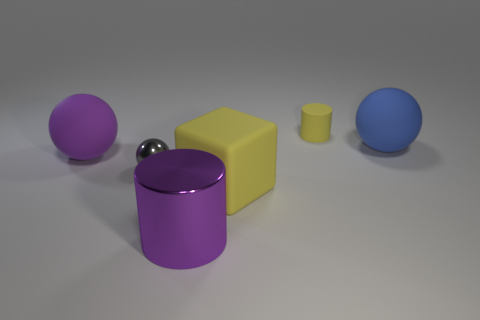Is there anything else that is the same shape as the large yellow rubber object?
Provide a short and direct response. No. What number of tiny yellow matte cylinders are on the left side of the sphere right of the yellow matte block?
Make the answer very short. 1. There is a sphere to the right of the matte cube; is it the same color as the large metallic cylinder?
Offer a very short reply. No. What number of things are either cylinders or yellow things that are behind the large cube?
Provide a short and direct response. 2. There is a big purple thing in front of the big purple matte sphere; does it have the same shape as the yellow rubber thing that is on the left side of the rubber cylinder?
Your response must be concise. No. Is there any other thing that is the same color as the matte cylinder?
Keep it short and to the point. Yes. The large blue object that is made of the same material as the yellow cube is what shape?
Provide a short and direct response. Sphere. What material is the thing that is behind the big purple sphere and in front of the yellow cylinder?
Ensure brevity in your answer.  Rubber. Do the big metallic object and the small cylinder have the same color?
Provide a succinct answer. No. What shape is the thing that is the same color as the big cylinder?
Provide a succinct answer. Sphere. 